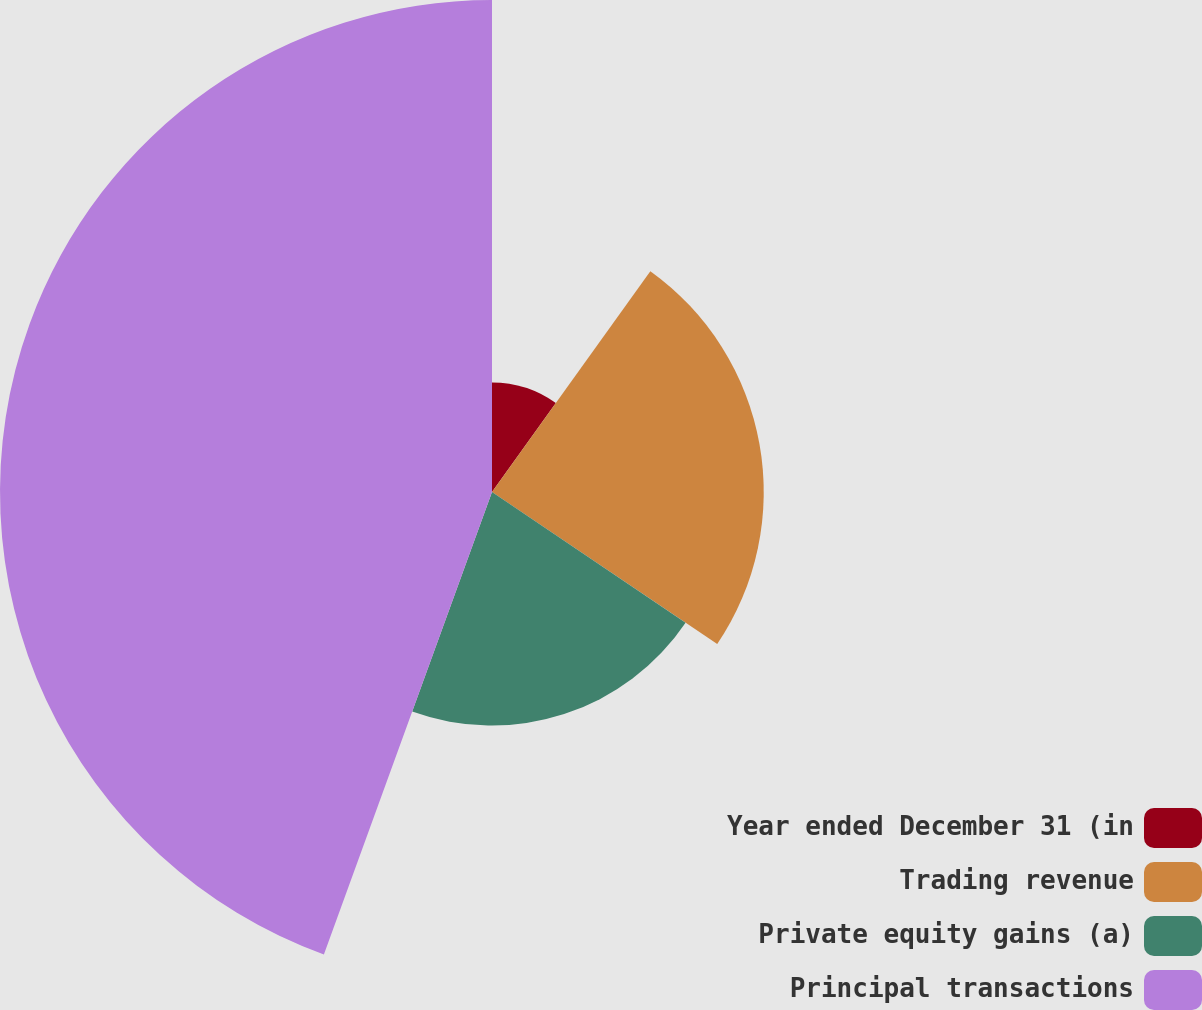Convert chart. <chart><loc_0><loc_0><loc_500><loc_500><pie_chart><fcel>Year ended December 31 (in<fcel>Trading revenue<fcel>Private equity gains (a)<fcel>Principal transactions<nl><fcel>9.9%<fcel>24.55%<fcel>21.1%<fcel>44.45%<nl></chart> 